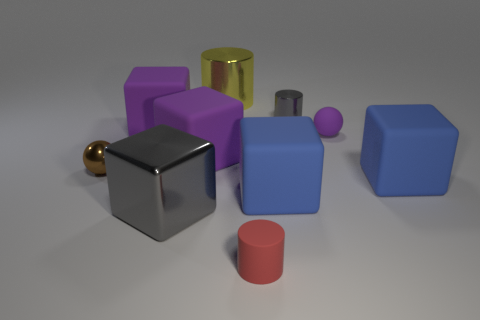Subtract 1 cubes. How many cubes are left? 4 Subtract all gray blocks. How many blocks are left? 4 Subtract all gray metallic cubes. How many cubes are left? 4 Subtract all green blocks. Subtract all yellow spheres. How many blocks are left? 5 Subtract all spheres. How many objects are left? 8 Subtract all big green objects. Subtract all small metal objects. How many objects are left? 8 Add 7 small red rubber cylinders. How many small red rubber cylinders are left? 8 Add 1 purple rubber balls. How many purple rubber balls exist? 2 Subtract 0 cyan balls. How many objects are left? 10 